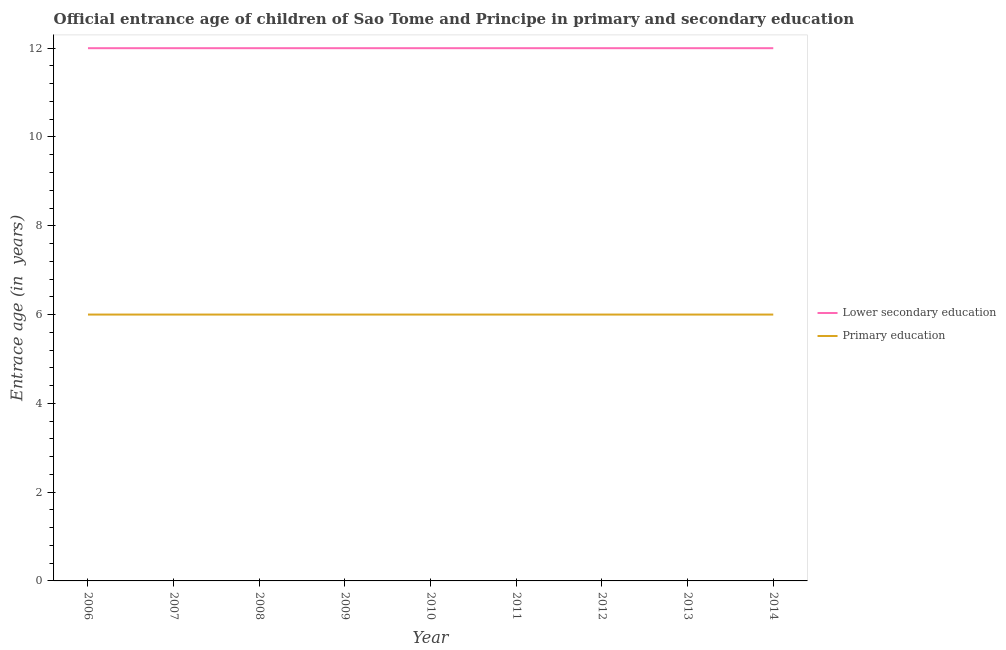How many different coloured lines are there?
Ensure brevity in your answer.  2. Is the number of lines equal to the number of legend labels?
Offer a very short reply. Yes. Across all years, what is the maximum entrance age of children in lower secondary education?
Ensure brevity in your answer.  12. Across all years, what is the minimum entrance age of children in lower secondary education?
Your answer should be compact. 12. In which year was the entrance age of chiildren in primary education maximum?
Ensure brevity in your answer.  2006. What is the total entrance age of children in lower secondary education in the graph?
Provide a short and direct response. 108. What is the difference between the entrance age of children in lower secondary education in 2013 and the entrance age of chiildren in primary education in 2008?
Keep it short and to the point. 6. What is the ratio of the entrance age of children in lower secondary education in 2007 to that in 2013?
Make the answer very short. 1. Is the entrance age of chiildren in primary education in 2009 less than that in 2012?
Keep it short and to the point. No. Is the difference between the entrance age of children in lower secondary education in 2009 and 2010 greater than the difference between the entrance age of chiildren in primary education in 2009 and 2010?
Your answer should be compact. No. In how many years, is the entrance age of chiildren in primary education greater than the average entrance age of chiildren in primary education taken over all years?
Keep it short and to the point. 0. Does the entrance age of children in lower secondary education monotonically increase over the years?
Provide a short and direct response. No. Is the entrance age of chiildren in primary education strictly greater than the entrance age of children in lower secondary education over the years?
Offer a very short reply. No. Is the entrance age of children in lower secondary education strictly less than the entrance age of chiildren in primary education over the years?
Your answer should be very brief. No. How many lines are there?
Provide a succinct answer. 2. Where does the legend appear in the graph?
Your answer should be compact. Center right. How many legend labels are there?
Make the answer very short. 2. How are the legend labels stacked?
Your response must be concise. Vertical. What is the title of the graph?
Offer a very short reply. Official entrance age of children of Sao Tome and Principe in primary and secondary education. What is the label or title of the Y-axis?
Provide a short and direct response. Entrace age (in  years). What is the Entrace age (in  years) of Primary education in 2006?
Give a very brief answer. 6. What is the Entrace age (in  years) of Primary education in 2007?
Offer a terse response. 6. What is the Entrace age (in  years) of Lower secondary education in 2009?
Your answer should be very brief. 12. What is the Entrace age (in  years) of Lower secondary education in 2012?
Keep it short and to the point. 12. What is the Entrace age (in  years) of Lower secondary education in 2013?
Your response must be concise. 12. What is the Entrace age (in  years) in Primary education in 2014?
Offer a very short reply. 6. Across all years, what is the maximum Entrace age (in  years) of Lower secondary education?
Keep it short and to the point. 12. Across all years, what is the maximum Entrace age (in  years) in Primary education?
Your response must be concise. 6. What is the total Entrace age (in  years) in Lower secondary education in the graph?
Offer a terse response. 108. What is the difference between the Entrace age (in  years) of Primary education in 2006 and that in 2007?
Give a very brief answer. 0. What is the difference between the Entrace age (in  years) of Lower secondary education in 2006 and that in 2008?
Your response must be concise. 0. What is the difference between the Entrace age (in  years) of Primary education in 2006 and that in 2010?
Ensure brevity in your answer.  0. What is the difference between the Entrace age (in  years) of Lower secondary education in 2006 and that in 2011?
Ensure brevity in your answer.  0. What is the difference between the Entrace age (in  years) of Primary education in 2006 and that in 2013?
Offer a terse response. 0. What is the difference between the Entrace age (in  years) in Lower secondary education in 2006 and that in 2014?
Make the answer very short. 0. What is the difference between the Entrace age (in  years) of Primary education in 2007 and that in 2008?
Your answer should be compact. 0. What is the difference between the Entrace age (in  years) in Lower secondary education in 2007 and that in 2009?
Ensure brevity in your answer.  0. What is the difference between the Entrace age (in  years) of Primary education in 2007 and that in 2009?
Make the answer very short. 0. What is the difference between the Entrace age (in  years) in Primary education in 2007 and that in 2013?
Provide a short and direct response. 0. What is the difference between the Entrace age (in  years) in Lower secondary education in 2007 and that in 2014?
Provide a succinct answer. 0. What is the difference between the Entrace age (in  years) in Primary education in 2008 and that in 2009?
Provide a succinct answer. 0. What is the difference between the Entrace age (in  years) of Lower secondary education in 2008 and that in 2010?
Keep it short and to the point. 0. What is the difference between the Entrace age (in  years) in Primary education in 2008 and that in 2010?
Make the answer very short. 0. What is the difference between the Entrace age (in  years) in Lower secondary education in 2008 and that in 2013?
Give a very brief answer. 0. What is the difference between the Entrace age (in  years) of Lower secondary education in 2008 and that in 2014?
Offer a very short reply. 0. What is the difference between the Entrace age (in  years) of Primary education in 2008 and that in 2014?
Ensure brevity in your answer.  0. What is the difference between the Entrace age (in  years) of Lower secondary education in 2009 and that in 2010?
Make the answer very short. 0. What is the difference between the Entrace age (in  years) in Lower secondary education in 2009 and that in 2011?
Give a very brief answer. 0. What is the difference between the Entrace age (in  years) of Primary education in 2009 and that in 2011?
Your response must be concise. 0. What is the difference between the Entrace age (in  years) in Primary education in 2009 and that in 2013?
Your response must be concise. 0. What is the difference between the Entrace age (in  years) in Primary education in 2009 and that in 2014?
Offer a very short reply. 0. What is the difference between the Entrace age (in  years) of Lower secondary education in 2010 and that in 2011?
Give a very brief answer. 0. What is the difference between the Entrace age (in  years) in Lower secondary education in 2010 and that in 2012?
Provide a short and direct response. 0. What is the difference between the Entrace age (in  years) in Primary education in 2010 and that in 2012?
Your response must be concise. 0. What is the difference between the Entrace age (in  years) in Lower secondary education in 2010 and that in 2013?
Your answer should be compact. 0. What is the difference between the Entrace age (in  years) of Primary education in 2010 and that in 2013?
Your response must be concise. 0. What is the difference between the Entrace age (in  years) in Primary education in 2010 and that in 2014?
Give a very brief answer. 0. What is the difference between the Entrace age (in  years) in Primary education in 2011 and that in 2012?
Make the answer very short. 0. What is the difference between the Entrace age (in  years) of Lower secondary education in 2012 and that in 2014?
Ensure brevity in your answer.  0. What is the difference between the Entrace age (in  years) of Primary education in 2012 and that in 2014?
Provide a succinct answer. 0. What is the difference between the Entrace age (in  years) of Lower secondary education in 2013 and that in 2014?
Make the answer very short. 0. What is the difference between the Entrace age (in  years) in Primary education in 2013 and that in 2014?
Offer a terse response. 0. What is the difference between the Entrace age (in  years) in Lower secondary education in 2006 and the Entrace age (in  years) in Primary education in 2007?
Your response must be concise. 6. What is the difference between the Entrace age (in  years) of Lower secondary education in 2006 and the Entrace age (in  years) of Primary education in 2014?
Provide a succinct answer. 6. What is the difference between the Entrace age (in  years) of Lower secondary education in 2007 and the Entrace age (in  years) of Primary education in 2010?
Keep it short and to the point. 6. What is the difference between the Entrace age (in  years) of Lower secondary education in 2007 and the Entrace age (in  years) of Primary education in 2011?
Offer a very short reply. 6. What is the difference between the Entrace age (in  years) in Lower secondary education in 2007 and the Entrace age (in  years) in Primary education in 2012?
Provide a succinct answer. 6. What is the difference between the Entrace age (in  years) in Lower secondary education in 2007 and the Entrace age (in  years) in Primary education in 2013?
Give a very brief answer. 6. What is the difference between the Entrace age (in  years) in Lower secondary education in 2007 and the Entrace age (in  years) in Primary education in 2014?
Your answer should be very brief. 6. What is the difference between the Entrace age (in  years) of Lower secondary education in 2008 and the Entrace age (in  years) of Primary education in 2010?
Keep it short and to the point. 6. What is the difference between the Entrace age (in  years) of Lower secondary education in 2008 and the Entrace age (in  years) of Primary education in 2011?
Offer a very short reply. 6. What is the difference between the Entrace age (in  years) of Lower secondary education in 2008 and the Entrace age (in  years) of Primary education in 2013?
Provide a short and direct response. 6. What is the difference between the Entrace age (in  years) of Lower secondary education in 2008 and the Entrace age (in  years) of Primary education in 2014?
Give a very brief answer. 6. What is the difference between the Entrace age (in  years) of Lower secondary education in 2009 and the Entrace age (in  years) of Primary education in 2010?
Offer a very short reply. 6. What is the difference between the Entrace age (in  years) of Lower secondary education in 2009 and the Entrace age (in  years) of Primary education in 2011?
Ensure brevity in your answer.  6. What is the difference between the Entrace age (in  years) in Lower secondary education in 2009 and the Entrace age (in  years) in Primary education in 2013?
Make the answer very short. 6. What is the difference between the Entrace age (in  years) of Lower secondary education in 2009 and the Entrace age (in  years) of Primary education in 2014?
Offer a terse response. 6. What is the difference between the Entrace age (in  years) in Lower secondary education in 2010 and the Entrace age (in  years) in Primary education in 2011?
Ensure brevity in your answer.  6. What is the difference between the Entrace age (in  years) of Lower secondary education in 2012 and the Entrace age (in  years) of Primary education in 2013?
Offer a terse response. 6. What is the difference between the Entrace age (in  years) of Lower secondary education in 2012 and the Entrace age (in  years) of Primary education in 2014?
Offer a terse response. 6. What is the average Entrace age (in  years) in Lower secondary education per year?
Offer a very short reply. 12. What is the average Entrace age (in  years) in Primary education per year?
Offer a terse response. 6. In the year 2006, what is the difference between the Entrace age (in  years) in Lower secondary education and Entrace age (in  years) in Primary education?
Provide a succinct answer. 6. In the year 2011, what is the difference between the Entrace age (in  years) of Lower secondary education and Entrace age (in  years) of Primary education?
Provide a succinct answer. 6. In the year 2014, what is the difference between the Entrace age (in  years) in Lower secondary education and Entrace age (in  years) in Primary education?
Keep it short and to the point. 6. What is the ratio of the Entrace age (in  years) in Lower secondary education in 2006 to that in 2007?
Provide a short and direct response. 1. What is the ratio of the Entrace age (in  years) of Primary education in 2006 to that in 2007?
Ensure brevity in your answer.  1. What is the ratio of the Entrace age (in  years) in Primary education in 2006 to that in 2008?
Provide a short and direct response. 1. What is the ratio of the Entrace age (in  years) of Lower secondary education in 2006 to that in 2009?
Ensure brevity in your answer.  1. What is the ratio of the Entrace age (in  years) of Primary education in 2006 to that in 2010?
Your answer should be very brief. 1. What is the ratio of the Entrace age (in  years) in Lower secondary education in 2006 to that in 2011?
Provide a succinct answer. 1. What is the ratio of the Entrace age (in  years) in Primary education in 2006 to that in 2012?
Provide a short and direct response. 1. What is the ratio of the Entrace age (in  years) of Lower secondary education in 2006 to that in 2013?
Provide a succinct answer. 1. What is the ratio of the Entrace age (in  years) of Primary education in 2006 to that in 2014?
Your answer should be very brief. 1. What is the ratio of the Entrace age (in  years) of Primary education in 2007 to that in 2009?
Your answer should be compact. 1. What is the ratio of the Entrace age (in  years) of Primary education in 2007 to that in 2012?
Provide a short and direct response. 1. What is the ratio of the Entrace age (in  years) in Lower secondary education in 2007 to that in 2013?
Keep it short and to the point. 1. What is the ratio of the Entrace age (in  years) of Lower secondary education in 2007 to that in 2014?
Offer a very short reply. 1. What is the ratio of the Entrace age (in  years) of Primary education in 2007 to that in 2014?
Keep it short and to the point. 1. What is the ratio of the Entrace age (in  years) of Primary education in 2008 to that in 2009?
Your answer should be very brief. 1. What is the ratio of the Entrace age (in  years) of Lower secondary education in 2008 to that in 2010?
Provide a succinct answer. 1. What is the ratio of the Entrace age (in  years) in Primary education in 2008 to that in 2010?
Make the answer very short. 1. What is the ratio of the Entrace age (in  years) of Lower secondary education in 2008 to that in 2011?
Make the answer very short. 1. What is the ratio of the Entrace age (in  years) in Lower secondary education in 2008 to that in 2013?
Make the answer very short. 1. What is the ratio of the Entrace age (in  years) of Primary education in 2008 to that in 2013?
Ensure brevity in your answer.  1. What is the ratio of the Entrace age (in  years) in Primary education in 2008 to that in 2014?
Ensure brevity in your answer.  1. What is the ratio of the Entrace age (in  years) in Lower secondary education in 2009 to that in 2010?
Give a very brief answer. 1. What is the ratio of the Entrace age (in  years) of Primary education in 2009 to that in 2010?
Offer a very short reply. 1. What is the ratio of the Entrace age (in  years) in Lower secondary education in 2009 to that in 2011?
Make the answer very short. 1. What is the ratio of the Entrace age (in  years) in Primary education in 2010 to that in 2011?
Provide a short and direct response. 1. What is the ratio of the Entrace age (in  years) of Primary education in 2010 to that in 2012?
Your response must be concise. 1. What is the ratio of the Entrace age (in  years) in Lower secondary education in 2010 to that in 2013?
Provide a short and direct response. 1. What is the ratio of the Entrace age (in  years) of Primary education in 2010 to that in 2013?
Offer a terse response. 1. What is the ratio of the Entrace age (in  years) of Primary education in 2010 to that in 2014?
Your response must be concise. 1. What is the ratio of the Entrace age (in  years) of Lower secondary education in 2011 to that in 2012?
Offer a terse response. 1. What is the ratio of the Entrace age (in  years) of Primary education in 2011 to that in 2013?
Offer a terse response. 1. What is the ratio of the Entrace age (in  years) of Primary education in 2011 to that in 2014?
Offer a very short reply. 1. What is the ratio of the Entrace age (in  years) of Lower secondary education in 2012 to that in 2013?
Provide a succinct answer. 1. What is the ratio of the Entrace age (in  years) of Primary education in 2012 to that in 2013?
Keep it short and to the point. 1. What is the ratio of the Entrace age (in  years) of Primary education in 2012 to that in 2014?
Your answer should be compact. 1. What is the ratio of the Entrace age (in  years) of Lower secondary education in 2013 to that in 2014?
Your response must be concise. 1. What is the ratio of the Entrace age (in  years) in Primary education in 2013 to that in 2014?
Make the answer very short. 1. What is the difference between the highest and the lowest Entrace age (in  years) in Lower secondary education?
Offer a terse response. 0. 